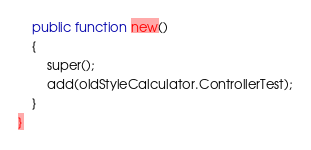Convert code to text. <code><loc_0><loc_0><loc_500><loc_500><_Haxe_>	public function new()
	{
		super();
		add(oldStyleCalculator.ControllerTest);
	}
}</code> 